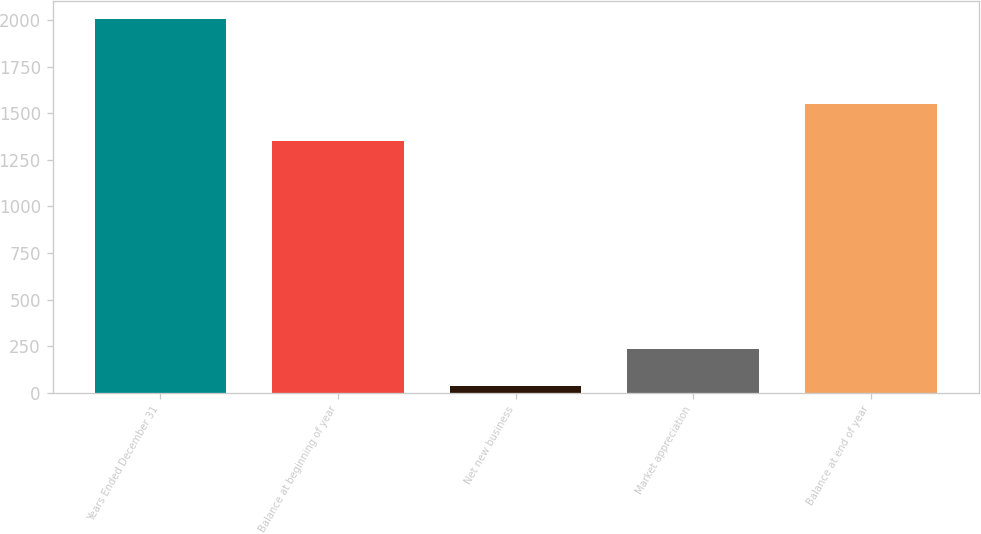Convert chart to OTSL. <chart><loc_0><loc_0><loc_500><loc_500><bar_chart><fcel>Years Ended December 31<fcel>Balance at beginning of year<fcel>Net new business<fcel>Market appreciation<fcel>Balance at end of year<nl><fcel>2005<fcel>1354<fcel>36<fcel>232.9<fcel>1550.9<nl></chart> 